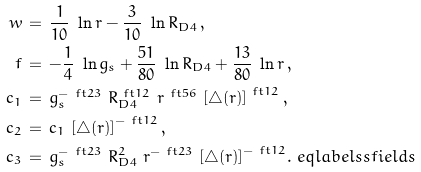Convert formula to latex. <formula><loc_0><loc_0><loc_500><loc_500>w & \, = \, \frac { 1 } { 1 0 } \ \ln { r } - \frac { 3 } { 1 0 } \ \ln { R _ { D 4 } } \, , \\ f & \, = \, - \frac { 1 } { 4 } \ \ln { g _ { s } } + \frac { 5 1 } { 8 0 } \ \ln { R _ { D 4 } } + \frac { 1 3 } { 8 0 } \ \ln { r } \, , \\ c _ { 1 } & \, = \, g _ { s } ^ { - \ f t { 2 } { 3 } } \ R _ { D 4 } ^ { \ f t 1 2 } \ r ^ { \ f t 5 6 } \ { [ \triangle ( r ) ] } ^ { \ f t 1 2 } \, , \\ c _ { 2 } & \, = \, c _ { 1 } \ { [ \triangle ( r ) ] } ^ { - \ f t 1 2 } \, , \\ c _ { 3 } & \, = \, { g _ { s } ^ { - \ f t { 2 } { 3 } } \ R _ { D 4 } ^ { 2 } } \ { r ^ { - \ f t 2 3 } \ { [ \triangle ( r ) ] } ^ { - \ f t 1 2 } } . \ e q l a b e l { s s f i e l d s }</formula> 